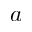Convert formula to latex. <formula><loc_0><loc_0><loc_500><loc_500>a</formula> 